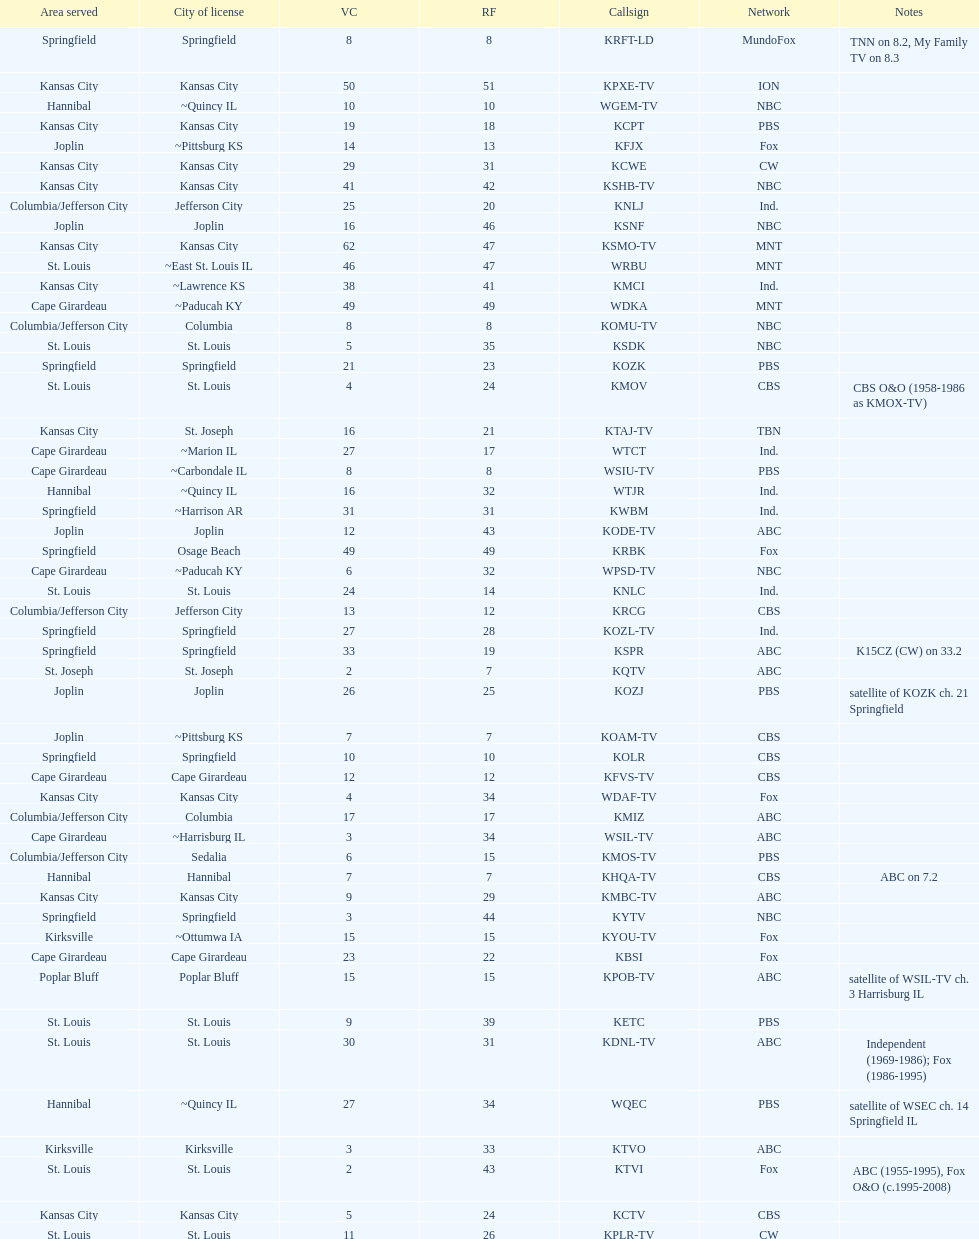How many are on the cbs network? 7. 